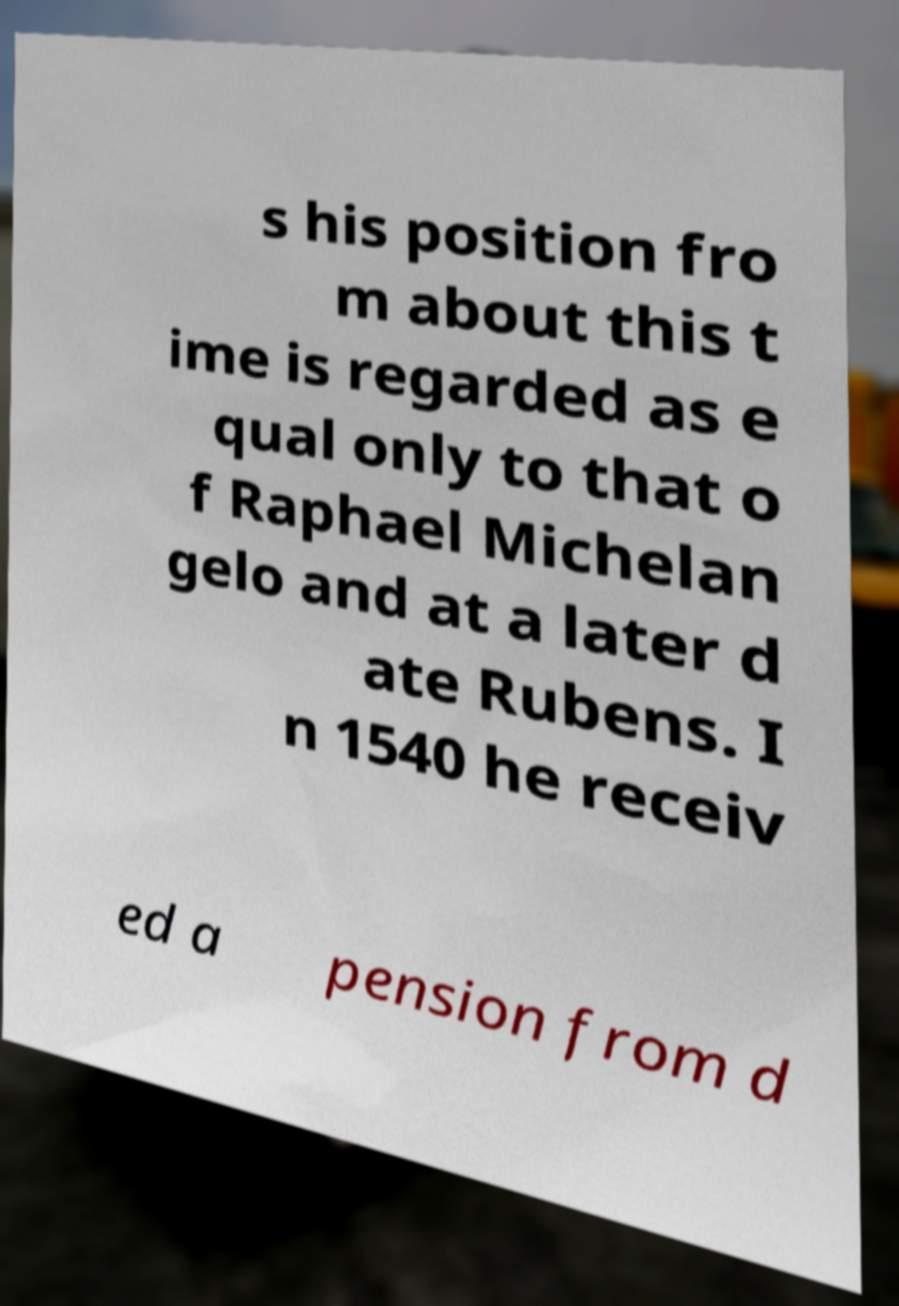Can you accurately transcribe the text from the provided image for me? s his position fro m about this t ime is regarded as e qual only to that o f Raphael Michelan gelo and at a later d ate Rubens. I n 1540 he receiv ed a pension from d 